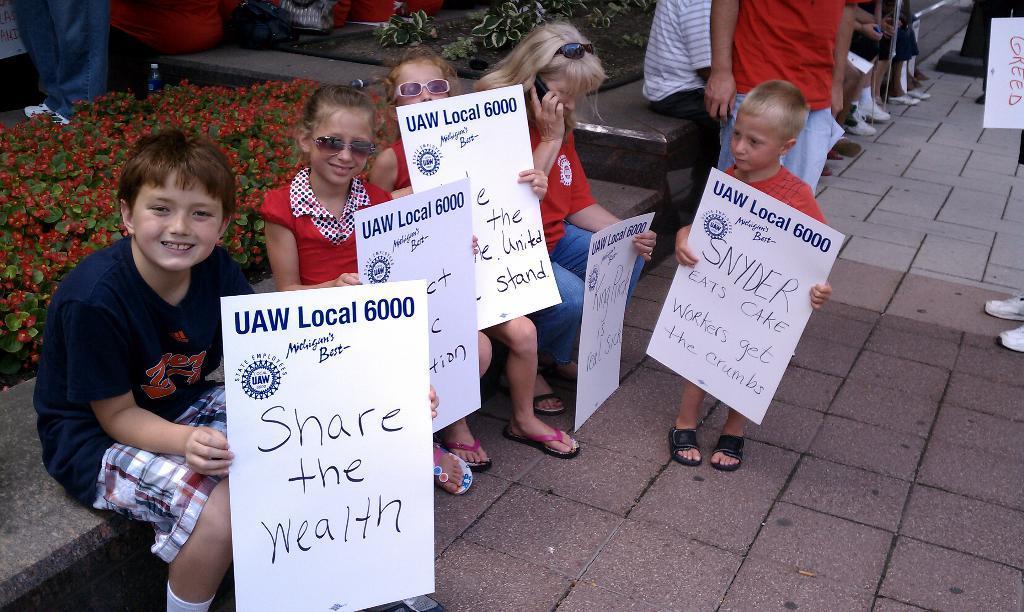In one or two sentences, can you explain what this image depicts? In this picture we can see a group of people on the ground, some people are sitting on the wall and some people are holding posters and in the background we can see plants, bottle and some objects. 